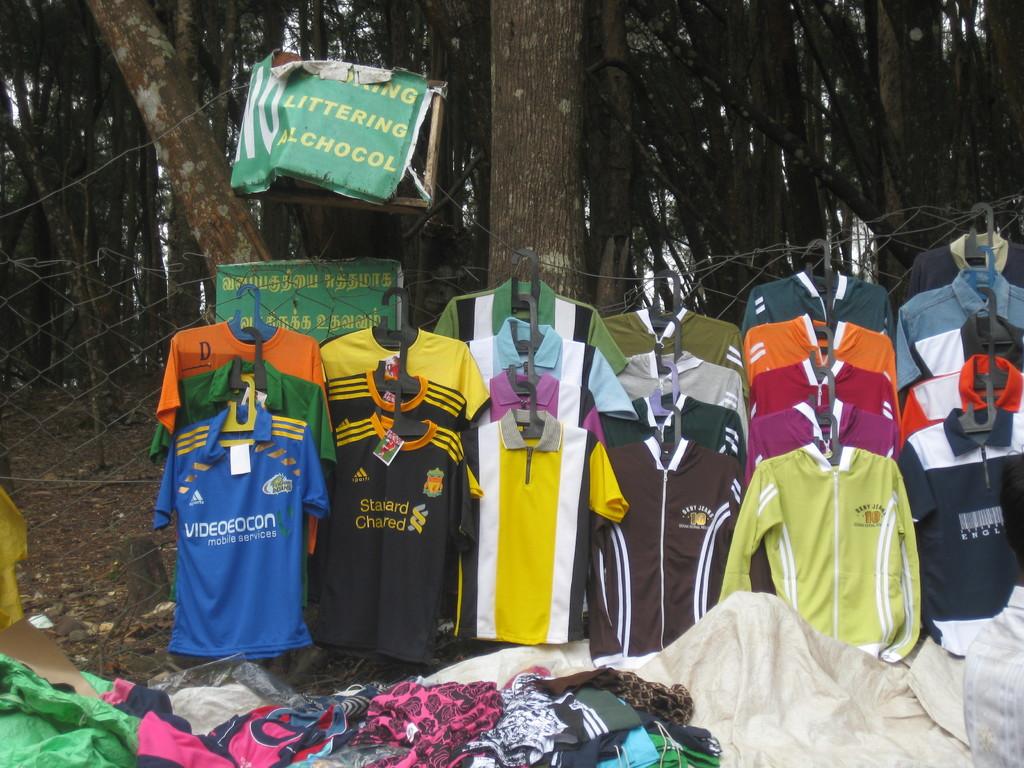What does the green sign at the top mention?
Your answer should be compact. Littering alchocol. 